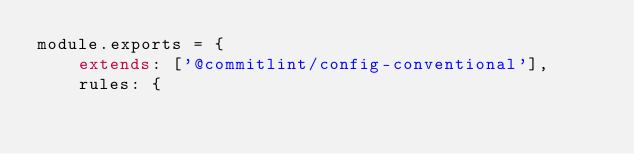Convert code to text. <code><loc_0><loc_0><loc_500><loc_500><_JavaScript_>module.exports = {
    extends: ['@commitlint/config-conventional'],
    rules: {</code> 